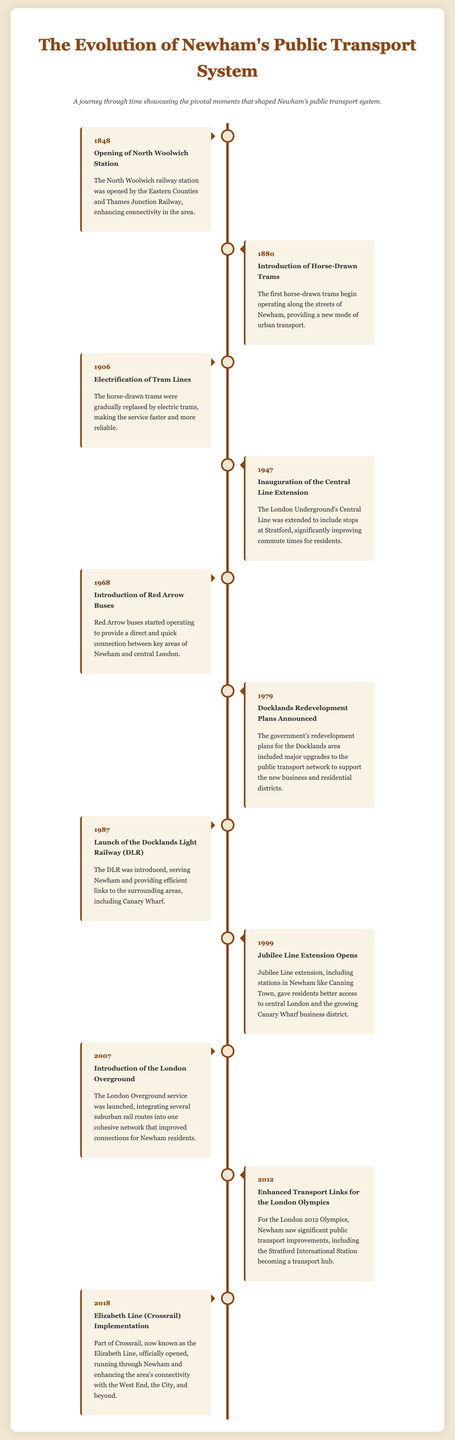What year was the North Woolwich Station opened? The year mentioned for the opening of North Woolwich Station in the document is 1848.
Answer: 1848 What mode of transport was introduced in 1880? The document states that horse-drawn trams were first introduced in 1880.
Answer: Horse-Drawn Trams Which line was extended in 1947? The document specifies that the Central Line was extended in 1947.
Answer: Central Line What significant transport service launched in 1987? The launch of the Docklands Light Railway (DLR) in 1987 is mentioned in the document.
Answer: Docklands Light Railway (DLR) In which year did the Jubilee Line Extension open? According to the document, the Jubilee Line Extension opened in 1999.
Answer: 1999 Why were significant transport improvements seen in 2012? The document explains that improvements were made for the London 2012 Olympics, which required enhanced transport links.
Answer: London 2012 Olympics What was the purpose of the Docklands Redevelopment Plans announced in 1979? The document indicates that the plans aimed to upgrade the public transport network to support new developments in Docklands.
Answer: Upgrade public transport network Describe the structure of the infographic. The document outlines a timeline structure with a series of events laid out in sequential order, showcasing major developments in Newham's public transport system.
Answer: Timeline of events What theme does the infographic convey about Newham? The infographic portrays the evolution and advancements in Newham's public transport system over time.
Answer: Evolution of public transport 